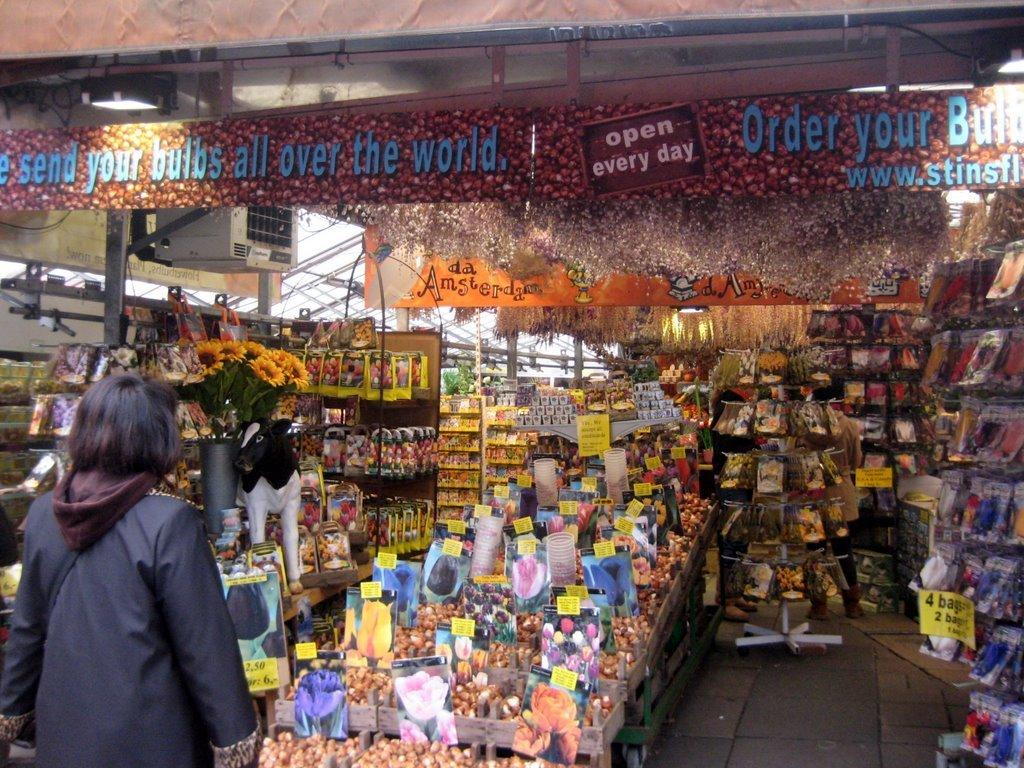Provide a one-sentence caption for the provided image. a flower bulb shop is open every day of the week. 